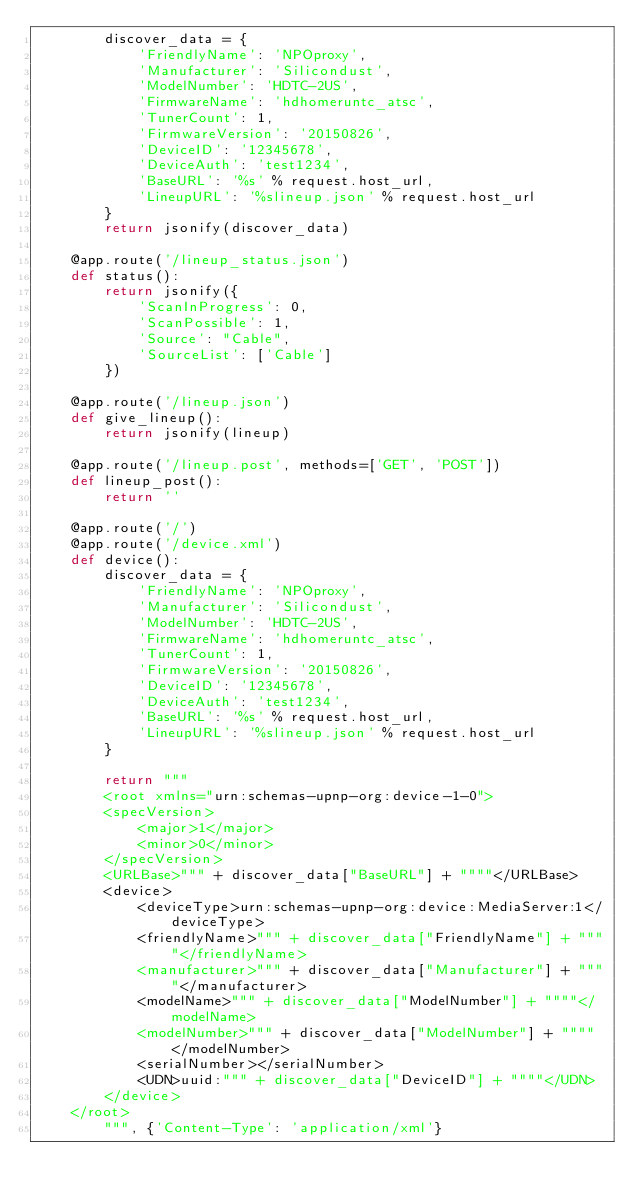Convert code to text. <code><loc_0><loc_0><loc_500><loc_500><_Python_>        discover_data = {
            'FriendlyName': 'NPOproxy',
            'Manufacturer': 'Silicondust',
            'ModelNumber': 'HDTC-2US',
            'FirmwareName': 'hdhomeruntc_atsc',
            'TunerCount': 1,
            'FirmwareVersion': '20150826',
            'DeviceID': '12345678',
            'DeviceAuth': 'test1234',
            'BaseURL': '%s' % request.host_url,
            'LineupURL': '%slineup.json' % request.host_url
        }
        return jsonify(discover_data)

    @app.route('/lineup_status.json')
    def status():
        return jsonify({
            'ScanInProgress': 0,
            'ScanPossible': 1,
            'Source': "Cable",
            'SourceList': ['Cable']
        })

    @app.route('/lineup.json')
    def give_lineup():
        return jsonify(lineup)

    @app.route('/lineup.post', methods=['GET', 'POST'])
    def lineup_post():
        return ''

    @app.route('/')
    @app.route('/device.xml')
    def device():
        discover_data = {
            'FriendlyName': 'NPOproxy',
            'Manufacturer': 'Silicondust',
            'ModelNumber': 'HDTC-2US',
            'FirmwareName': 'hdhomeruntc_atsc',
            'TunerCount': 1,
            'FirmwareVersion': '20150826',
            'DeviceID': '12345678',
            'DeviceAuth': 'test1234',
            'BaseURL': '%s' % request.host_url,
            'LineupURL': '%slineup.json' % request.host_url
        }

        return """
        <root xmlns="urn:schemas-upnp-org:device-1-0">
        <specVersion>
            <major>1</major>
            <minor>0</minor>
        </specVersion>
        <URLBase>""" + discover_data["BaseURL"] + """"</URLBase>
        <device>
            <deviceType>urn:schemas-upnp-org:device:MediaServer:1</deviceType>
            <friendlyName>""" + discover_data["FriendlyName"] + """"</friendlyName>
            <manufacturer>""" + discover_data["Manufacturer"] + """"</manufacturer>
            <modelName>""" + discover_data["ModelNumber"] + """"</modelName>
            <modelNumber>""" + discover_data["ModelNumber"] + """"</modelNumber>
            <serialNumber></serialNumber>
            <UDN>uuid:""" + discover_data["DeviceID"] + """"</UDN>
        </device>
    </root>
        """, {'Content-Type': 'application/xml'}
</code> 